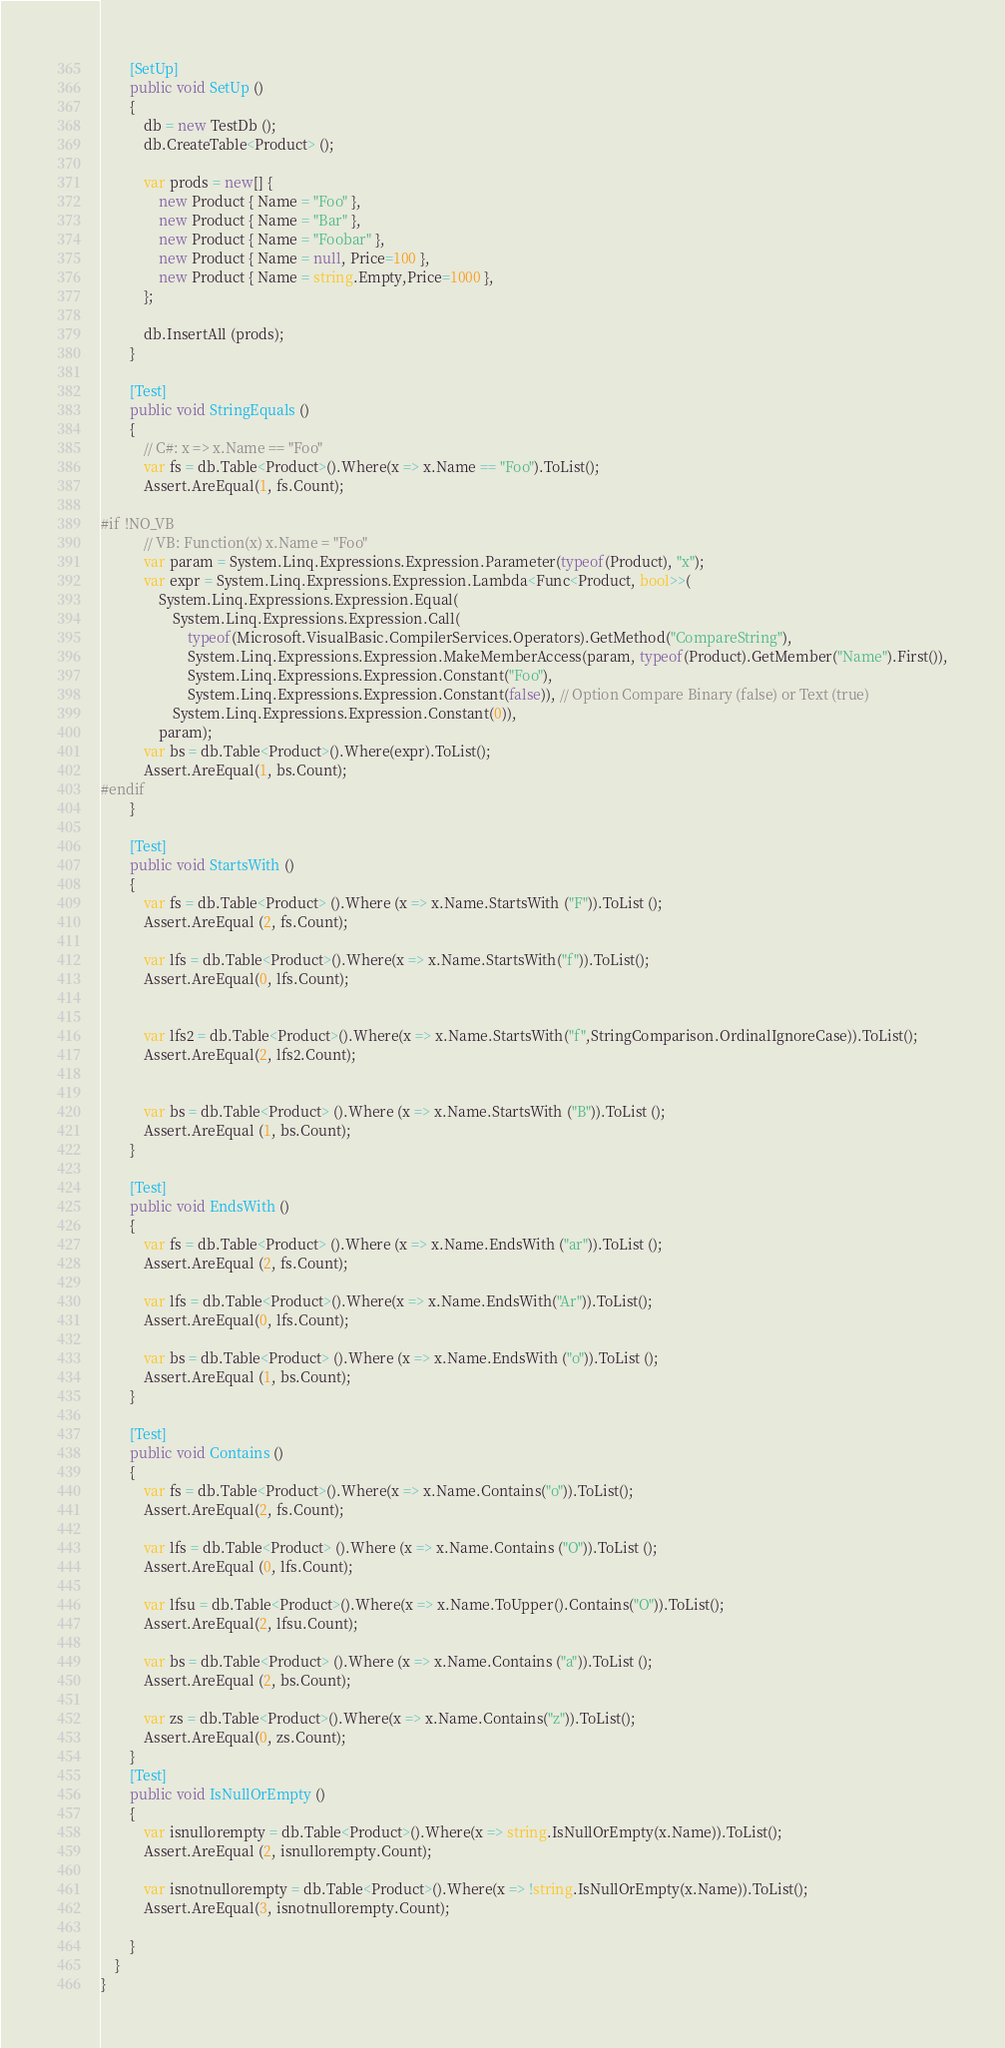Convert code to text. <code><loc_0><loc_0><loc_500><loc_500><_C#_>
		[SetUp]
		public void SetUp ()
		{
			db = new TestDb ();
			db.CreateTable<Product> ();

			var prods = new[] {
				new Product { Name = "Foo" },
				new Product { Name = "Bar" },
				new Product { Name = "Foobar" },
				new Product { Name = null, Price=100 },
				new Product { Name = string.Empty,Price=1000 },
			};

			db.InsertAll (prods);
		}

		[Test]
		public void StringEquals ()
		{
			// C#: x => x.Name == "Foo"
			var fs = db.Table<Product>().Where(x => x.Name == "Foo").ToList();
			Assert.AreEqual(1, fs.Count);

#if !NO_VB
			// VB: Function(x) x.Name = "Foo"
			var param = System.Linq.Expressions.Expression.Parameter(typeof(Product), "x");
			var expr = System.Linq.Expressions.Expression.Lambda<Func<Product, bool>>(
				System.Linq.Expressions.Expression.Equal(
					System.Linq.Expressions.Expression.Call(
						typeof(Microsoft.VisualBasic.CompilerServices.Operators).GetMethod("CompareString"),
						System.Linq.Expressions.Expression.MakeMemberAccess(param, typeof(Product).GetMember("Name").First()),
						System.Linq.Expressions.Expression.Constant("Foo"),
						System.Linq.Expressions.Expression.Constant(false)), // Option Compare Binary (false) or Text (true)
					System.Linq.Expressions.Expression.Constant(0)),
				param);
			var bs = db.Table<Product>().Where(expr).ToList();
			Assert.AreEqual(1, bs.Count);
#endif
		}

		[Test]
		public void StartsWith ()
		{
			var fs = db.Table<Product> ().Where (x => x.Name.StartsWith ("F")).ToList ();
			Assert.AreEqual (2, fs.Count);

			var lfs = db.Table<Product>().Where(x => x.Name.StartsWith("f")).ToList();
			Assert.AreEqual(0, lfs.Count);


			var lfs2 = db.Table<Product>().Where(x => x.Name.StartsWith("f",StringComparison.OrdinalIgnoreCase)).ToList();
			Assert.AreEqual(2, lfs2.Count);


			var bs = db.Table<Product> ().Where (x => x.Name.StartsWith ("B")).ToList ();
			Assert.AreEqual (1, bs.Count);
		}

		[Test]
		public void EndsWith ()
		{
			var fs = db.Table<Product> ().Where (x => x.Name.EndsWith ("ar")).ToList ();
			Assert.AreEqual (2, fs.Count);

			var lfs = db.Table<Product>().Where(x => x.Name.EndsWith("Ar")).ToList();
			Assert.AreEqual(0, lfs.Count);

			var bs = db.Table<Product> ().Where (x => x.Name.EndsWith ("o")).ToList ();
			Assert.AreEqual (1, bs.Count);
		}

		[Test]
		public void Contains ()
		{
			var fs = db.Table<Product>().Where(x => x.Name.Contains("o")).ToList();
			Assert.AreEqual(2, fs.Count);

			var lfs = db.Table<Product> ().Where (x => x.Name.Contains ("O")).ToList ();
			Assert.AreEqual (0, lfs.Count);

			var lfsu = db.Table<Product>().Where(x => x.Name.ToUpper().Contains("O")).ToList();
			Assert.AreEqual(2, lfsu.Count);

			var bs = db.Table<Product> ().Where (x => x.Name.Contains ("a")).ToList ();
			Assert.AreEqual (2, bs.Count);

			var zs = db.Table<Product>().Where(x => x.Name.Contains("z")).ToList();
			Assert.AreEqual(0, zs.Count);
		}
		[Test]
		public void IsNullOrEmpty ()
		{
			var isnullorempty = db.Table<Product>().Where(x => string.IsNullOrEmpty(x.Name)).ToList();
			Assert.AreEqual (2, isnullorempty.Count);

			var isnotnullorempty = db.Table<Product>().Where(x => !string.IsNullOrEmpty(x.Name)).ToList();
			Assert.AreEqual(3, isnotnullorempty.Count);

		}
	}
}
</code> 